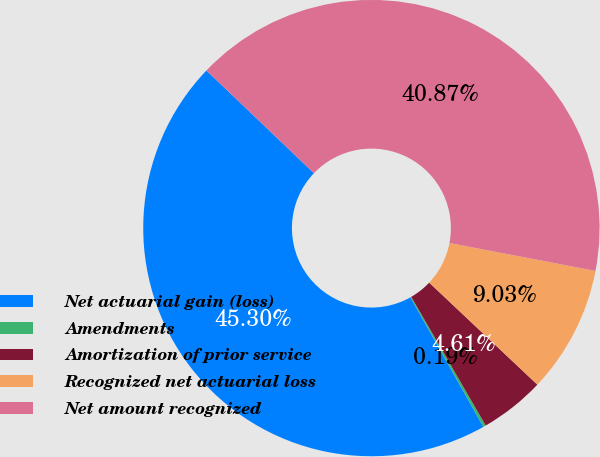Convert chart. <chart><loc_0><loc_0><loc_500><loc_500><pie_chart><fcel>Net actuarial gain (loss)<fcel>Amendments<fcel>Amortization of prior service<fcel>Recognized net actuarial loss<fcel>Net amount recognized<nl><fcel>45.3%<fcel>0.19%<fcel>4.61%<fcel>9.03%<fcel>40.87%<nl></chart> 